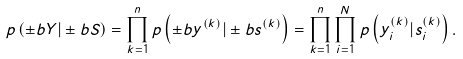<formula> <loc_0><loc_0><loc_500><loc_500>p \left ( \pm b { Y } | \pm b { S } \right ) = \prod _ { k = 1 } ^ { n } p \left ( \pm b { y } ^ { ( k ) } | \pm b { s } ^ { ( k ) } \right ) = \prod _ { k = 1 } ^ { n } \prod _ { i = 1 } ^ { N } p \left ( y _ { i } ^ { ( k ) } | s _ { i } ^ { ( k ) } \right ) .</formula> 